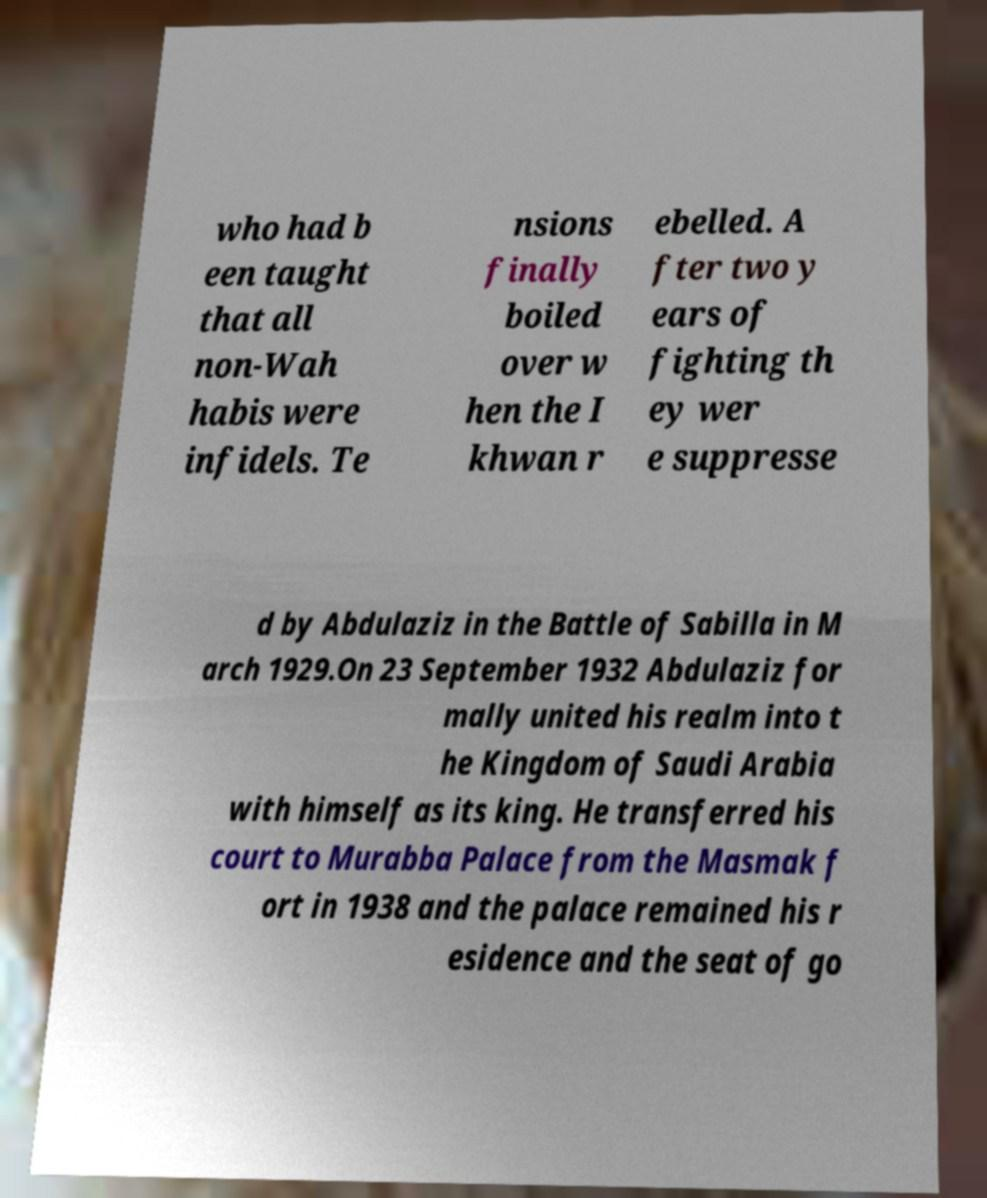I need the written content from this picture converted into text. Can you do that? who had b een taught that all non-Wah habis were infidels. Te nsions finally boiled over w hen the I khwan r ebelled. A fter two y ears of fighting th ey wer e suppresse d by Abdulaziz in the Battle of Sabilla in M arch 1929.On 23 September 1932 Abdulaziz for mally united his realm into t he Kingdom of Saudi Arabia with himself as its king. He transferred his court to Murabba Palace from the Masmak f ort in 1938 and the palace remained his r esidence and the seat of go 